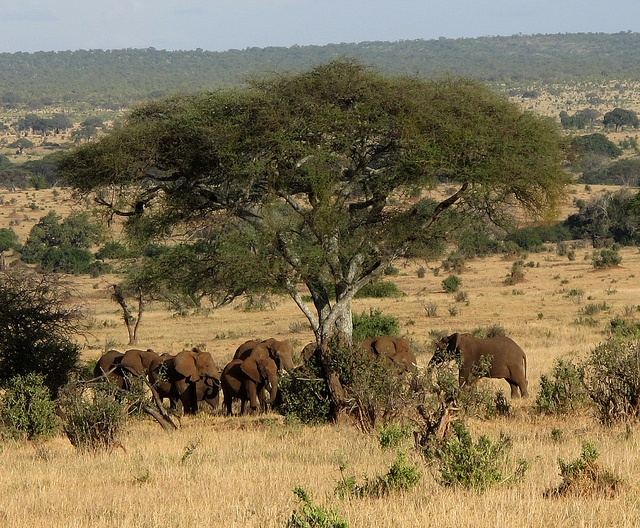Describe the objects in this image and their specific colors. I can see elephant in lightgray, maroon, black, and gray tones, elephant in lightgray, black, maroon, and brown tones, elephant in lightgray, black, maroon, and brown tones, elephant in lightgray, olive, maroon, black, and brown tones, and elephant in lightgray, black, maroon, and gray tones in this image. 